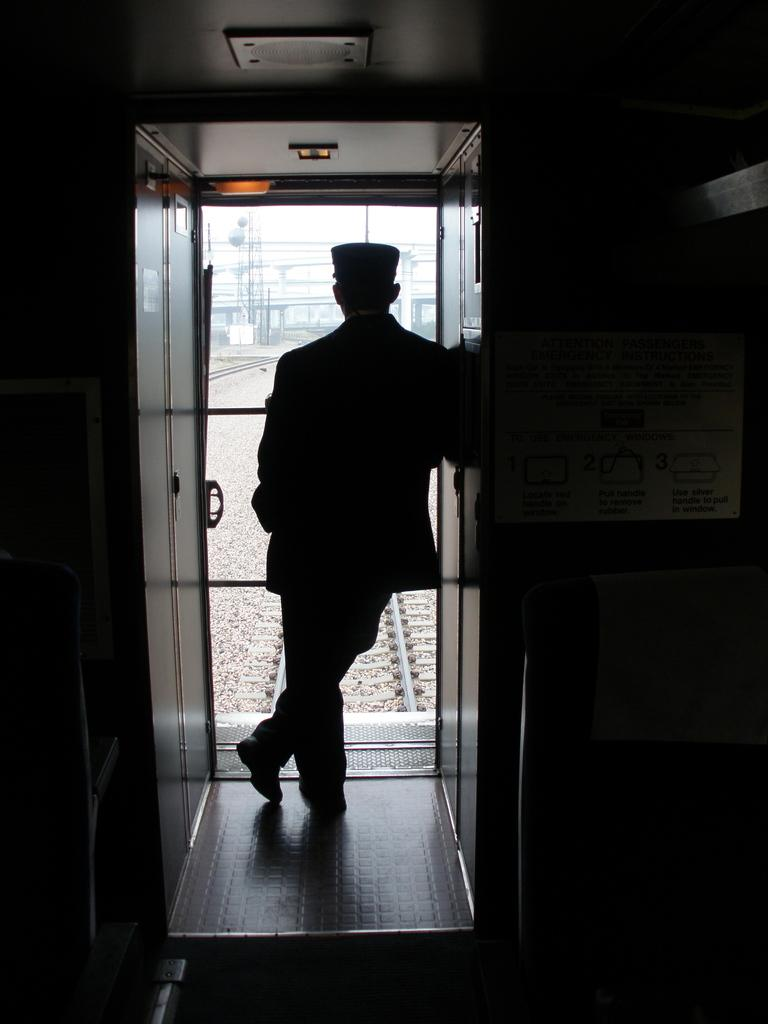What is the main subject of the image? There is a person standing in the image. What can be seen in the background of the image? There is a door, poles, tracks, and trees in the background of the image. What is the color of the sky in the image? The sky is white in color. Can you see any boats or ships in the harbor in the image? There is no harbor or boats visible in the image. What type of mitten is the person wearing in the image? The person is not wearing a mitten in the image. 